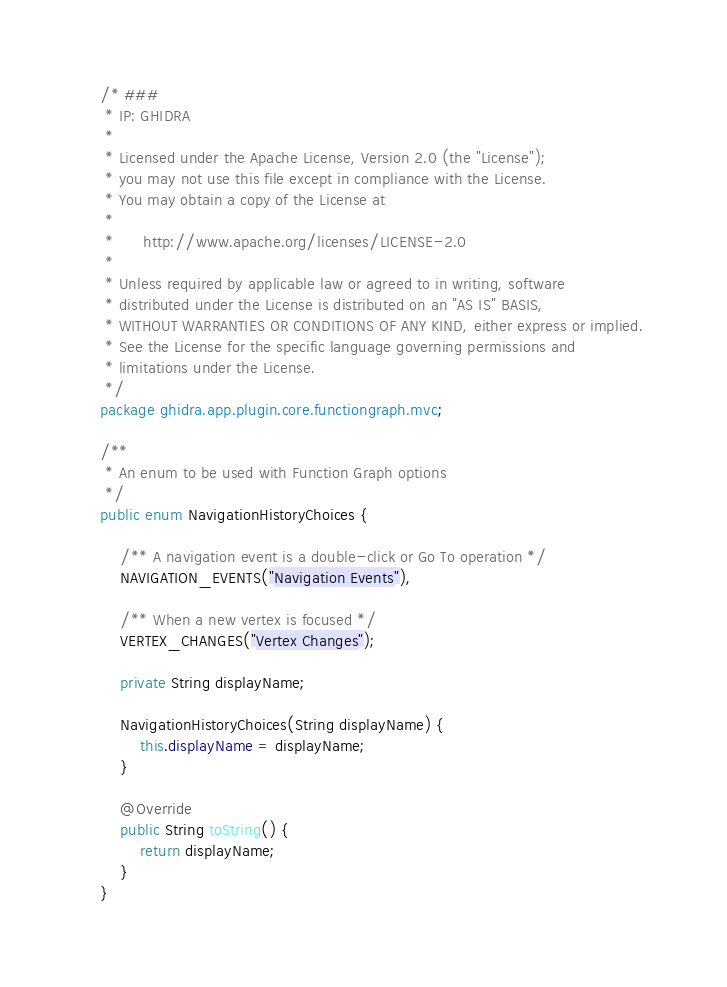<code> <loc_0><loc_0><loc_500><loc_500><_Java_>/* ###
 * IP: GHIDRA
 *
 * Licensed under the Apache License, Version 2.0 (the "License");
 * you may not use this file except in compliance with the License.
 * You may obtain a copy of the License at
 * 
 *      http://www.apache.org/licenses/LICENSE-2.0
 * 
 * Unless required by applicable law or agreed to in writing, software
 * distributed under the License is distributed on an "AS IS" BASIS,
 * WITHOUT WARRANTIES OR CONDITIONS OF ANY KIND, either express or implied.
 * See the License for the specific language governing permissions and
 * limitations under the License.
 */
package ghidra.app.plugin.core.functiongraph.mvc;

/**
 * An enum to be used with Function Graph options
 */
public enum NavigationHistoryChoices {

	/** A navigation event is a double-click or Go To operation */
	NAVIGATION_EVENTS("Navigation Events"),

	/** When a new vertex is focused */
	VERTEX_CHANGES("Vertex Changes");

	private String displayName;

	NavigationHistoryChoices(String displayName) {
		this.displayName = displayName;
	}

	@Override
	public String toString() {
		return displayName;
	}
}
</code> 